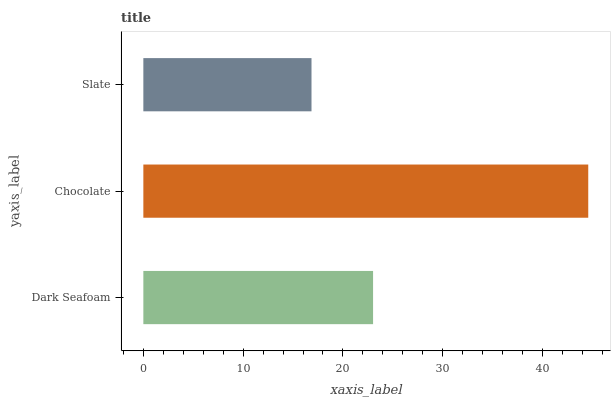Is Slate the minimum?
Answer yes or no. Yes. Is Chocolate the maximum?
Answer yes or no. Yes. Is Chocolate the minimum?
Answer yes or no. No. Is Slate the maximum?
Answer yes or no. No. Is Chocolate greater than Slate?
Answer yes or no. Yes. Is Slate less than Chocolate?
Answer yes or no. Yes. Is Slate greater than Chocolate?
Answer yes or no. No. Is Chocolate less than Slate?
Answer yes or no. No. Is Dark Seafoam the high median?
Answer yes or no. Yes. Is Dark Seafoam the low median?
Answer yes or no. Yes. Is Chocolate the high median?
Answer yes or no. No. Is Chocolate the low median?
Answer yes or no. No. 